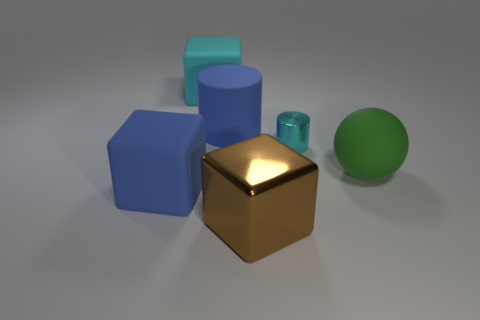Can you describe the texture of the matte object in the center? The matte object at the center has a smooth surface without much reflection. It's finished in a solid, matte gold color that suggests it could have a metallic texture. 